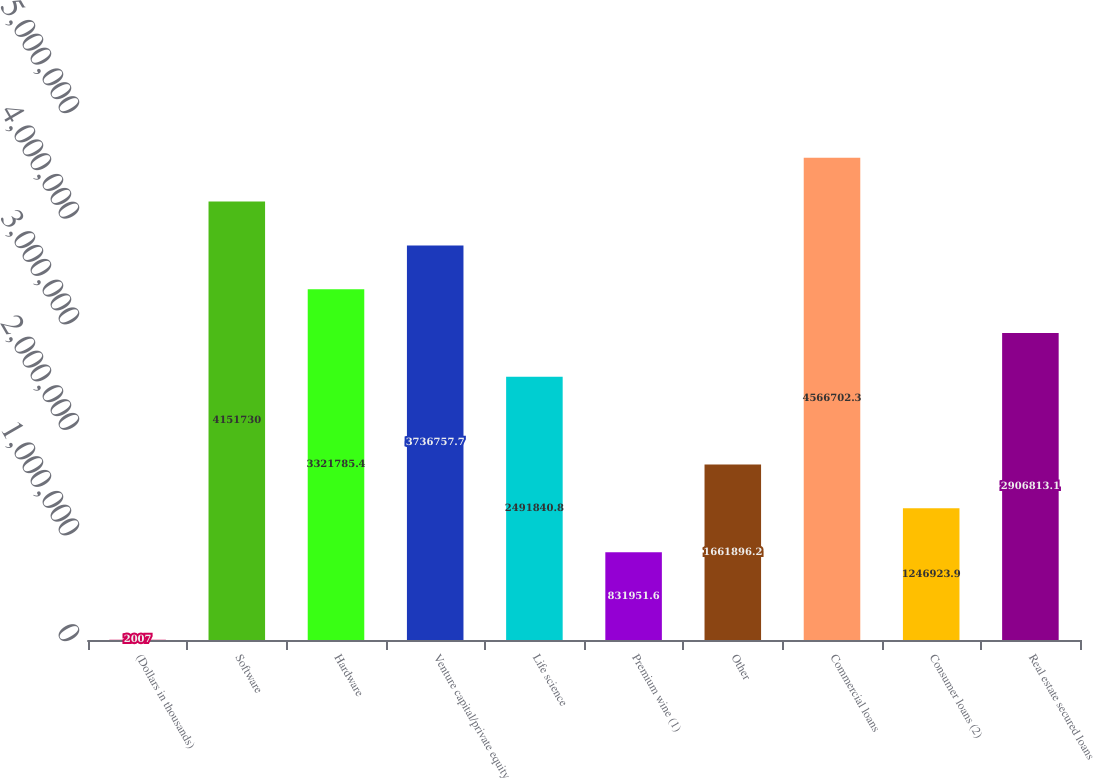Convert chart to OTSL. <chart><loc_0><loc_0><loc_500><loc_500><bar_chart><fcel>(Dollars in thousands)<fcel>Software<fcel>Hardware<fcel>Venture capital/private equity<fcel>Life science<fcel>Premium wine (1)<fcel>Other<fcel>Commercial loans<fcel>Consumer loans (2)<fcel>Real estate secured loans<nl><fcel>2007<fcel>4.15173e+06<fcel>3.32179e+06<fcel>3.73676e+06<fcel>2.49184e+06<fcel>831952<fcel>1.6619e+06<fcel>4.5667e+06<fcel>1.24692e+06<fcel>2.90681e+06<nl></chart> 